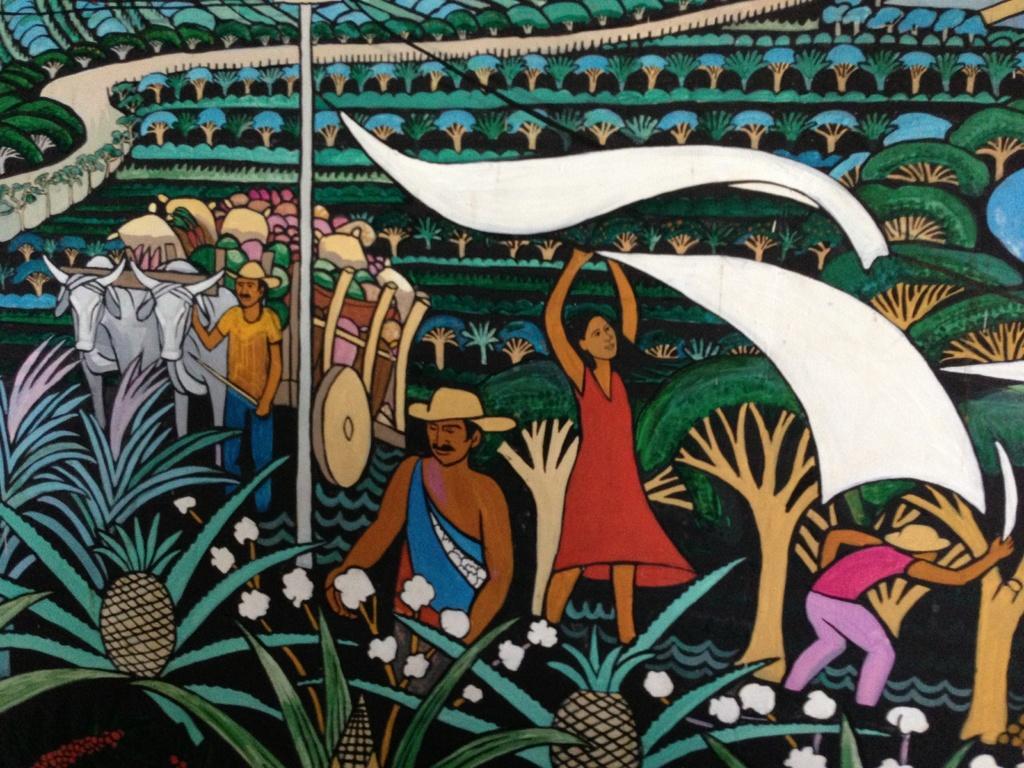Describe this image in one or two sentences. In this image there is a wall with a few paintings of men, women, plants, trees and a bullock cart on it. 